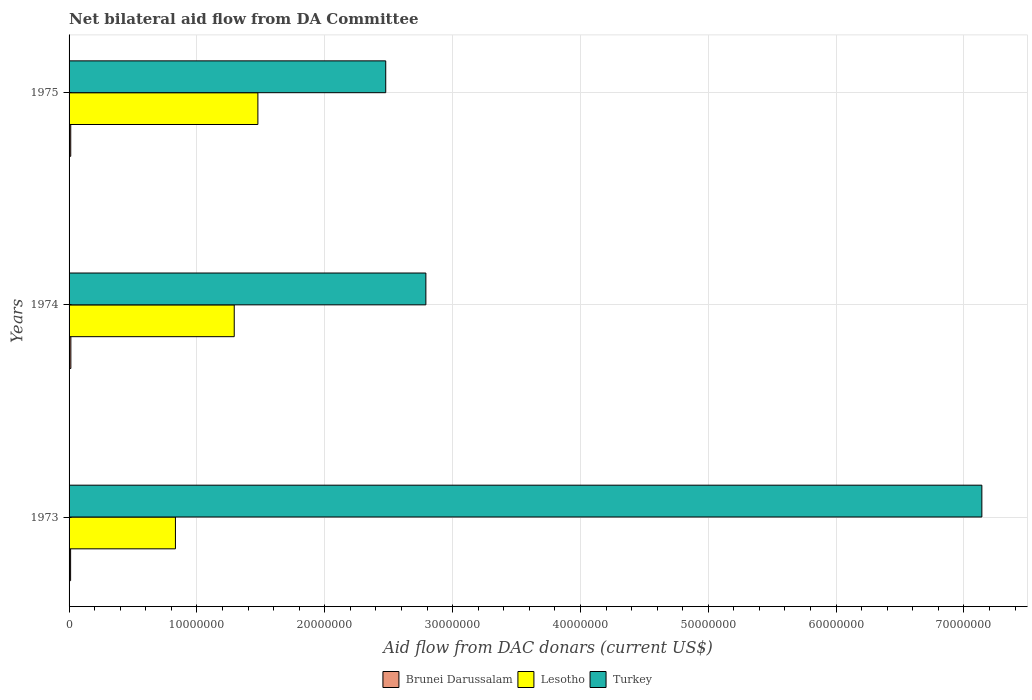How many different coloured bars are there?
Your answer should be very brief. 3. How many groups of bars are there?
Ensure brevity in your answer.  3. How many bars are there on the 1st tick from the top?
Your answer should be very brief. 3. What is the label of the 2nd group of bars from the top?
Provide a short and direct response. 1974. What is the aid flow in in Lesotho in 1973?
Provide a short and direct response. 8.32e+06. Across all years, what is the maximum aid flow in in Brunei Darussalam?
Your answer should be very brief. 1.40e+05. Across all years, what is the minimum aid flow in in Turkey?
Offer a very short reply. 2.48e+07. What is the difference between the aid flow in in Brunei Darussalam in 1974 and that in 1975?
Your answer should be very brief. 10000. What is the difference between the aid flow in in Brunei Darussalam in 1973 and the aid flow in in Lesotho in 1975?
Give a very brief answer. -1.46e+07. What is the average aid flow in in Turkey per year?
Offer a terse response. 4.14e+07. In the year 1974, what is the difference between the aid flow in in Lesotho and aid flow in in Brunei Darussalam?
Your response must be concise. 1.28e+07. What is the ratio of the aid flow in in Turkey in 1973 to that in 1974?
Keep it short and to the point. 2.56. Is the aid flow in in Brunei Darussalam in 1973 less than that in 1974?
Offer a very short reply. Yes. What is the difference between the highest and the lowest aid flow in in Lesotho?
Provide a short and direct response. 6.45e+06. In how many years, is the aid flow in in Turkey greater than the average aid flow in in Turkey taken over all years?
Ensure brevity in your answer.  1. What does the 2nd bar from the top in 1975 represents?
Your response must be concise. Lesotho. What does the 2nd bar from the bottom in 1975 represents?
Provide a succinct answer. Lesotho. Is it the case that in every year, the sum of the aid flow in in Lesotho and aid flow in in Turkey is greater than the aid flow in in Brunei Darussalam?
Your response must be concise. Yes. How many bars are there?
Offer a very short reply. 9. Are all the bars in the graph horizontal?
Your response must be concise. Yes. How many years are there in the graph?
Give a very brief answer. 3. Are the values on the major ticks of X-axis written in scientific E-notation?
Your response must be concise. No. Does the graph contain grids?
Your answer should be very brief. Yes. How many legend labels are there?
Ensure brevity in your answer.  3. How are the legend labels stacked?
Keep it short and to the point. Horizontal. What is the title of the graph?
Your response must be concise. Net bilateral aid flow from DA Committee. What is the label or title of the X-axis?
Ensure brevity in your answer.  Aid flow from DAC donars (current US$). What is the label or title of the Y-axis?
Provide a short and direct response. Years. What is the Aid flow from DAC donars (current US$) in Brunei Darussalam in 1973?
Give a very brief answer. 1.20e+05. What is the Aid flow from DAC donars (current US$) in Lesotho in 1973?
Offer a very short reply. 8.32e+06. What is the Aid flow from DAC donars (current US$) of Turkey in 1973?
Provide a succinct answer. 7.14e+07. What is the Aid flow from DAC donars (current US$) of Lesotho in 1974?
Your response must be concise. 1.29e+07. What is the Aid flow from DAC donars (current US$) in Turkey in 1974?
Make the answer very short. 2.79e+07. What is the Aid flow from DAC donars (current US$) of Lesotho in 1975?
Give a very brief answer. 1.48e+07. What is the Aid flow from DAC donars (current US$) in Turkey in 1975?
Offer a very short reply. 2.48e+07. Across all years, what is the maximum Aid flow from DAC donars (current US$) of Brunei Darussalam?
Give a very brief answer. 1.40e+05. Across all years, what is the maximum Aid flow from DAC donars (current US$) in Lesotho?
Your response must be concise. 1.48e+07. Across all years, what is the maximum Aid flow from DAC donars (current US$) in Turkey?
Offer a terse response. 7.14e+07. Across all years, what is the minimum Aid flow from DAC donars (current US$) in Lesotho?
Your answer should be very brief. 8.32e+06. Across all years, what is the minimum Aid flow from DAC donars (current US$) of Turkey?
Your answer should be compact. 2.48e+07. What is the total Aid flow from DAC donars (current US$) in Lesotho in the graph?
Offer a terse response. 3.60e+07. What is the total Aid flow from DAC donars (current US$) in Turkey in the graph?
Make the answer very short. 1.24e+08. What is the difference between the Aid flow from DAC donars (current US$) of Lesotho in 1973 and that in 1974?
Keep it short and to the point. -4.60e+06. What is the difference between the Aid flow from DAC donars (current US$) of Turkey in 1973 and that in 1974?
Keep it short and to the point. 4.35e+07. What is the difference between the Aid flow from DAC donars (current US$) of Brunei Darussalam in 1973 and that in 1975?
Keep it short and to the point. -10000. What is the difference between the Aid flow from DAC donars (current US$) of Lesotho in 1973 and that in 1975?
Offer a very short reply. -6.45e+06. What is the difference between the Aid flow from DAC donars (current US$) of Turkey in 1973 and that in 1975?
Ensure brevity in your answer.  4.66e+07. What is the difference between the Aid flow from DAC donars (current US$) of Lesotho in 1974 and that in 1975?
Offer a very short reply. -1.85e+06. What is the difference between the Aid flow from DAC donars (current US$) in Turkey in 1974 and that in 1975?
Your response must be concise. 3.14e+06. What is the difference between the Aid flow from DAC donars (current US$) in Brunei Darussalam in 1973 and the Aid flow from DAC donars (current US$) in Lesotho in 1974?
Your answer should be compact. -1.28e+07. What is the difference between the Aid flow from DAC donars (current US$) in Brunei Darussalam in 1973 and the Aid flow from DAC donars (current US$) in Turkey in 1974?
Ensure brevity in your answer.  -2.78e+07. What is the difference between the Aid flow from DAC donars (current US$) in Lesotho in 1973 and the Aid flow from DAC donars (current US$) in Turkey in 1974?
Offer a terse response. -1.96e+07. What is the difference between the Aid flow from DAC donars (current US$) in Brunei Darussalam in 1973 and the Aid flow from DAC donars (current US$) in Lesotho in 1975?
Offer a terse response. -1.46e+07. What is the difference between the Aid flow from DAC donars (current US$) in Brunei Darussalam in 1973 and the Aid flow from DAC donars (current US$) in Turkey in 1975?
Your answer should be very brief. -2.46e+07. What is the difference between the Aid flow from DAC donars (current US$) in Lesotho in 1973 and the Aid flow from DAC donars (current US$) in Turkey in 1975?
Ensure brevity in your answer.  -1.64e+07. What is the difference between the Aid flow from DAC donars (current US$) in Brunei Darussalam in 1974 and the Aid flow from DAC donars (current US$) in Lesotho in 1975?
Provide a short and direct response. -1.46e+07. What is the difference between the Aid flow from DAC donars (current US$) of Brunei Darussalam in 1974 and the Aid flow from DAC donars (current US$) of Turkey in 1975?
Your response must be concise. -2.46e+07. What is the difference between the Aid flow from DAC donars (current US$) of Lesotho in 1974 and the Aid flow from DAC donars (current US$) of Turkey in 1975?
Provide a short and direct response. -1.18e+07. What is the average Aid flow from DAC donars (current US$) of Lesotho per year?
Your answer should be compact. 1.20e+07. What is the average Aid flow from DAC donars (current US$) in Turkey per year?
Offer a very short reply. 4.14e+07. In the year 1973, what is the difference between the Aid flow from DAC donars (current US$) of Brunei Darussalam and Aid flow from DAC donars (current US$) of Lesotho?
Your answer should be very brief. -8.20e+06. In the year 1973, what is the difference between the Aid flow from DAC donars (current US$) in Brunei Darussalam and Aid flow from DAC donars (current US$) in Turkey?
Your answer should be very brief. -7.13e+07. In the year 1973, what is the difference between the Aid flow from DAC donars (current US$) of Lesotho and Aid flow from DAC donars (current US$) of Turkey?
Your response must be concise. -6.31e+07. In the year 1974, what is the difference between the Aid flow from DAC donars (current US$) of Brunei Darussalam and Aid flow from DAC donars (current US$) of Lesotho?
Your answer should be very brief. -1.28e+07. In the year 1974, what is the difference between the Aid flow from DAC donars (current US$) of Brunei Darussalam and Aid flow from DAC donars (current US$) of Turkey?
Provide a short and direct response. -2.78e+07. In the year 1974, what is the difference between the Aid flow from DAC donars (current US$) of Lesotho and Aid flow from DAC donars (current US$) of Turkey?
Your response must be concise. -1.50e+07. In the year 1975, what is the difference between the Aid flow from DAC donars (current US$) of Brunei Darussalam and Aid flow from DAC donars (current US$) of Lesotho?
Give a very brief answer. -1.46e+07. In the year 1975, what is the difference between the Aid flow from DAC donars (current US$) of Brunei Darussalam and Aid flow from DAC donars (current US$) of Turkey?
Provide a short and direct response. -2.46e+07. In the year 1975, what is the difference between the Aid flow from DAC donars (current US$) in Lesotho and Aid flow from DAC donars (current US$) in Turkey?
Keep it short and to the point. -1.00e+07. What is the ratio of the Aid flow from DAC donars (current US$) in Brunei Darussalam in 1973 to that in 1974?
Ensure brevity in your answer.  0.86. What is the ratio of the Aid flow from DAC donars (current US$) in Lesotho in 1973 to that in 1974?
Offer a very short reply. 0.64. What is the ratio of the Aid flow from DAC donars (current US$) of Turkey in 1973 to that in 1974?
Keep it short and to the point. 2.56. What is the ratio of the Aid flow from DAC donars (current US$) of Lesotho in 1973 to that in 1975?
Ensure brevity in your answer.  0.56. What is the ratio of the Aid flow from DAC donars (current US$) in Turkey in 1973 to that in 1975?
Make the answer very short. 2.88. What is the ratio of the Aid flow from DAC donars (current US$) in Lesotho in 1974 to that in 1975?
Your response must be concise. 0.87. What is the ratio of the Aid flow from DAC donars (current US$) in Turkey in 1974 to that in 1975?
Ensure brevity in your answer.  1.13. What is the difference between the highest and the second highest Aid flow from DAC donars (current US$) of Brunei Darussalam?
Make the answer very short. 10000. What is the difference between the highest and the second highest Aid flow from DAC donars (current US$) of Lesotho?
Your response must be concise. 1.85e+06. What is the difference between the highest and the second highest Aid flow from DAC donars (current US$) in Turkey?
Offer a terse response. 4.35e+07. What is the difference between the highest and the lowest Aid flow from DAC donars (current US$) of Lesotho?
Your answer should be compact. 6.45e+06. What is the difference between the highest and the lowest Aid flow from DAC donars (current US$) of Turkey?
Make the answer very short. 4.66e+07. 